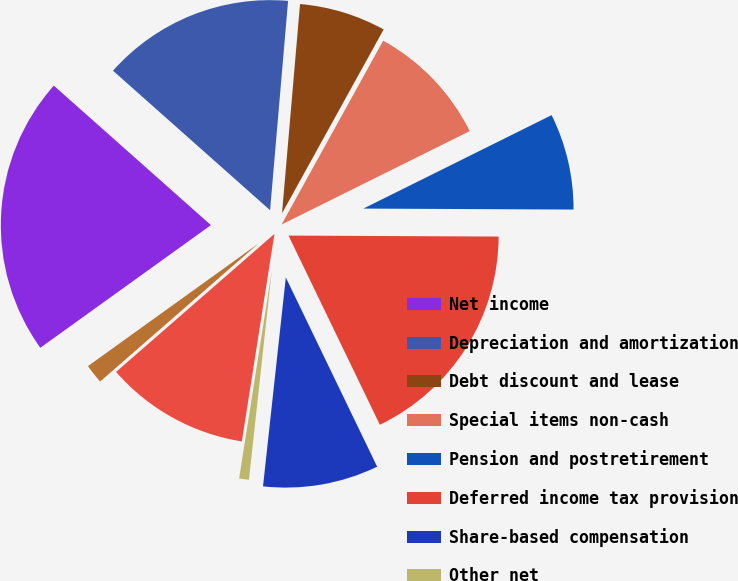Convert chart to OTSL. <chart><loc_0><loc_0><loc_500><loc_500><pie_chart><fcel>Net income<fcel>Depreciation and amortization<fcel>Debt discount and lease<fcel>Special items non-cash<fcel>Pension and postretirement<fcel>Deferred income tax provision<fcel>Share-based compensation<fcel>Other net<fcel>Decrease (increase) in<fcel>Increase in other assets<nl><fcel>21.48%<fcel>14.81%<fcel>6.67%<fcel>9.63%<fcel>7.41%<fcel>17.77%<fcel>8.89%<fcel>0.75%<fcel>11.11%<fcel>1.49%<nl></chart> 